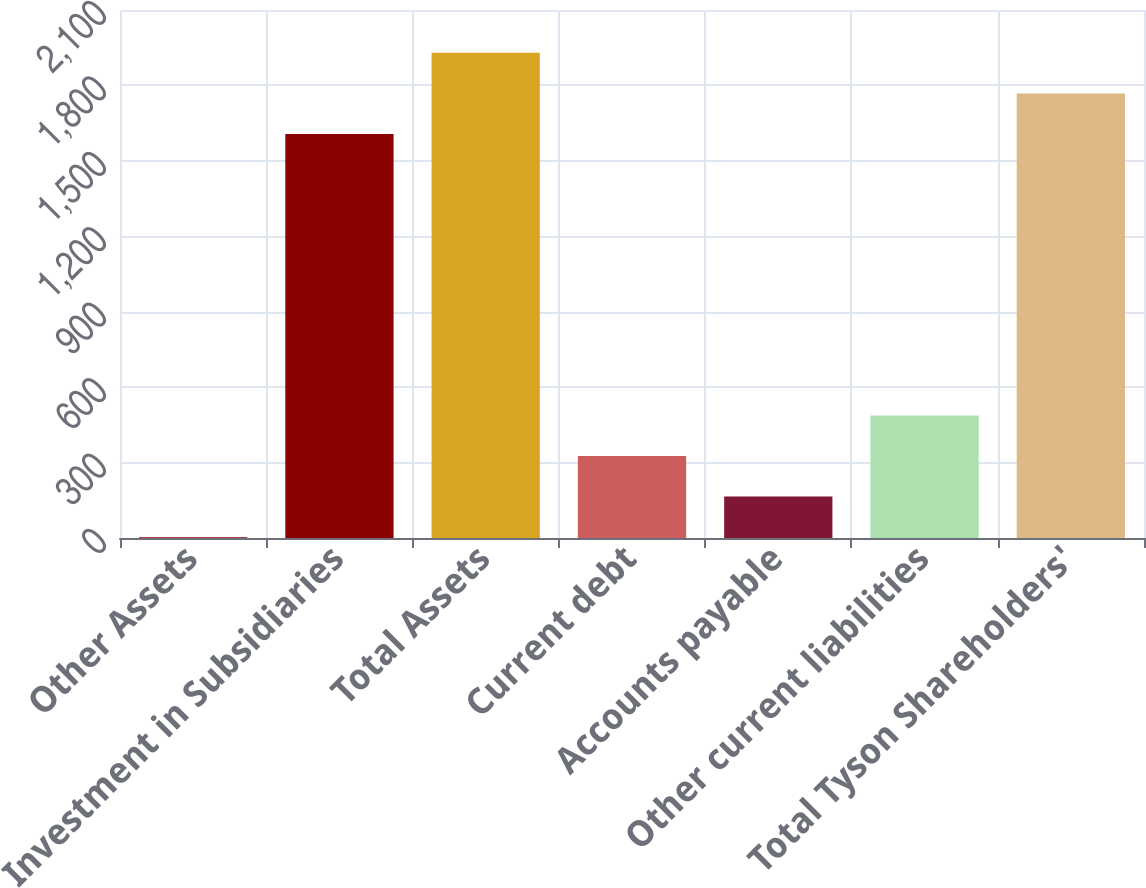<chart> <loc_0><loc_0><loc_500><loc_500><bar_chart><fcel>Other Assets<fcel>Investment in Subsidiaries<fcel>Total Assets<fcel>Current debt<fcel>Accounts payable<fcel>Other current liabilities<fcel>Total Tyson Shareholders'<nl><fcel>3.38<fcel>1607<fcel>1929.52<fcel>325.9<fcel>164.64<fcel>487.16<fcel>1768.26<nl></chart> 